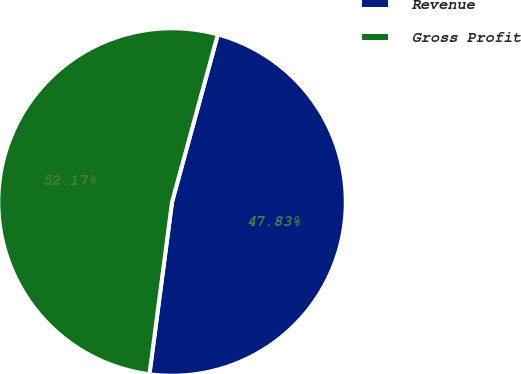<chart> <loc_0><loc_0><loc_500><loc_500><pie_chart><fcel>Revenue<fcel>Gross Profit<nl><fcel>47.83%<fcel>52.17%<nl></chart> 